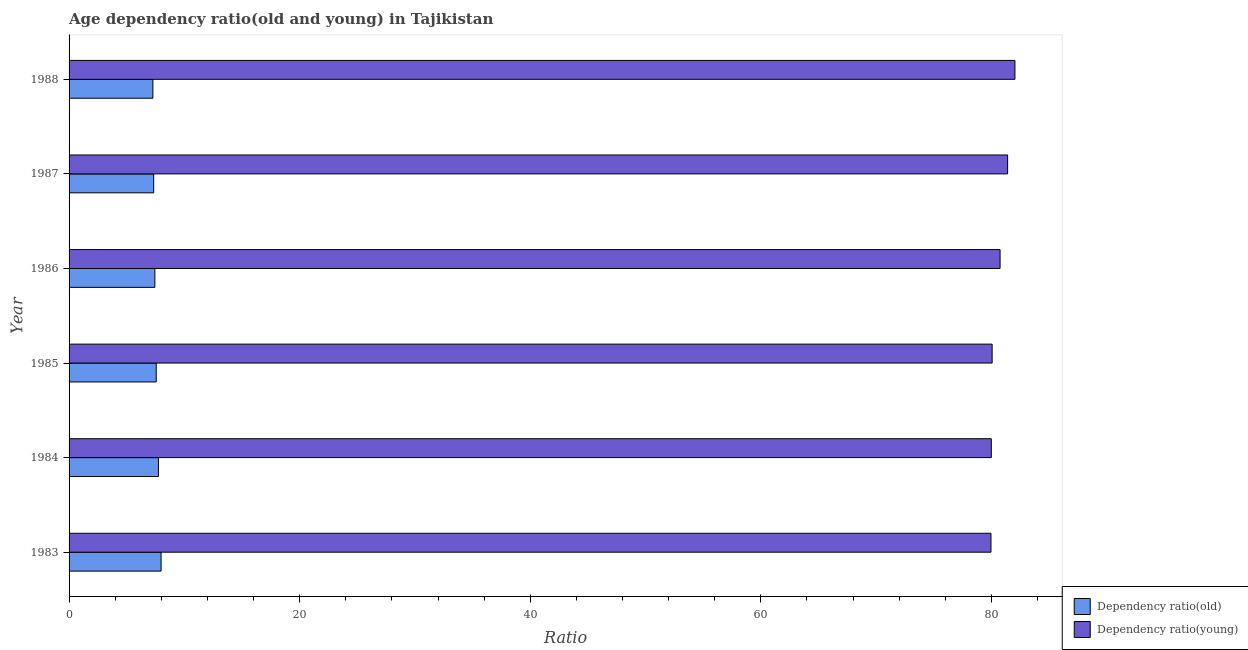How many groups of bars are there?
Keep it short and to the point. 6. What is the label of the 5th group of bars from the top?
Provide a succinct answer. 1984. What is the age dependency ratio(young) in 1988?
Provide a short and direct response. 82.04. Across all years, what is the maximum age dependency ratio(old)?
Your answer should be compact. 7.98. Across all years, what is the minimum age dependency ratio(old)?
Offer a very short reply. 7.27. In which year was the age dependency ratio(old) maximum?
Your answer should be compact. 1983. In which year was the age dependency ratio(young) minimum?
Your answer should be very brief. 1983. What is the total age dependency ratio(young) in the graph?
Your response must be concise. 484.23. What is the difference between the age dependency ratio(young) in 1986 and that in 1987?
Provide a succinct answer. -0.65. What is the difference between the age dependency ratio(old) in 1984 and the age dependency ratio(young) in 1986?
Provide a succinct answer. -73. What is the average age dependency ratio(old) per year?
Your response must be concise. 7.56. In the year 1988, what is the difference between the age dependency ratio(young) and age dependency ratio(old)?
Provide a short and direct response. 74.77. In how many years, is the age dependency ratio(young) greater than 40 ?
Provide a succinct answer. 6. Is the age dependency ratio(old) in 1985 less than that in 1987?
Provide a succinct answer. No. What is the difference between the highest and the second highest age dependency ratio(young)?
Your answer should be very brief. 0.64. What is the difference between the highest and the lowest age dependency ratio(young)?
Offer a very short reply. 2.08. In how many years, is the age dependency ratio(young) greater than the average age dependency ratio(young) taken over all years?
Your answer should be compact. 3. What does the 1st bar from the top in 1983 represents?
Offer a very short reply. Dependency ratio(young). What does the 1st bar from the bottom in 1983 represents?
Offer a very short reply. Dependency ratio(old). How many bars are there?
Give a very brief answer. 12. Are all the bars in the graph horizontal?
Offer a terse response. Yes. What is the difference between two consecutive major ticks on the X-axis?
Ensure brevity in your answer.  20. Are the values on the major ticks of X-axis written in scientific E-notation?
Make the answer very short. No. How many legend labels are there?
Provide a short and direct response. 2. How are the legend labels stacked?
Provide a short and direct response. Vertical. What is the title of the graph?
Make the answer very short. Age dependency ratio(old and young) in Tajikistan. What is the label or title of the X-axis?
Give a very brief answer. Ratio. What is the Ratio in Dependency ratio(old) in 1983?
Provide a succinct answer. 7.98. What is the Ratio of Dependency ratio(young) in 1983?
Give a very brief answer. 79.96. What is the Ratio in Dependency ratio(old) in 1984?
Keep it short and to the point. 7.75. What is the Ratio in Dependency ratio(young) in 1984?
Give a very brief answer. 79.99. What is the Ratio of Dependency ratio(old) in 1985?
Give a very brief answer. 7.56. What is the Ratio in Dependency ratio(young) in 1985?
Your answer should be compact. 80.07. What is the Ratio of Dependency ratio(old) in 1986?
Your answer should be compact. 7.44. What is the Ratio of Dependency ratio(young) in 1986?
Ensure brevity in your answer.  80.75. What is the Ratio of Dependency ratio(old) in 1987?
Offer a terse response. 7.34. What is the Ratio in Dependency ratio(young) in 1987?
Provide a succinct answer. 81.41. What is the Ratio in Dependency ratio(old) in 1988?
Your response must be concise. 7.27. What is the Ratio of Dependency ratio(young) in 1988?
Offer a very short reply. 82.04. Across all years, what is the maximum Ratio in Dependency ratio(old)?
Provide a succinct answer. 7.98. Across all years, what is the maximum Ratio in Dependency ratio(young)?
Ensure brevity in your answer.  82.04. Across all years, what is the minimum Ratio in Dependency ratio(old)?
Your response must be concise. 7.27. Across all years, what is the minimum Ratio in Dependency ratio(young)?
Ensure brevity in your answer.  79.96. What is the total Ratio of Dependency ratio(old) in the graph?
Provide a succinct answer. 45.35. What is the total Ratio of Dependency ratio(young) in the graph?
Offer a very short reply. 484.23. What is the difference between the Ratio in Dependency ratio(old) in 1983 and that in 1984?
Ensure brevity in your answer.  0.23. What is the difference between the Ratio of Dependency ratio(young) in 1983 and that in 1984?
Offer a terse response. -0.03. What is the difference between the Ratio of Dependency ratio(old) in 1983 and that in 1985?
Offer a terse response. 0.42. What is the difference between the Ratio of Dependency ratio(young) in 1983 and that in 1985?
Offer a terse response. -0.1. What is the difference between the Ratio of Dependency ratio(old) in 1983 and that in 1986?
Your response must be concise. 0.54. What is the difference between the Ratio of Dependency ratio(young) in 1983 and that in 1986?
Your answer should be compact. -0.79. What is the difference between the Ratio of Dependency ratio(old) in 1983 and that in 1987?
Keep it short and to the point. 0.64. What is the difference between the Ratio of Dependency ratio(young) in 1983 and that in 1987?
Your answer should be compact. -1.44. What is the difference between the Ratio in Dependency ratio(old) in 1983 and that in 1988?
Offer a very short reply. 0.71. What is the difference between the Ratio in Dependency ratio(young) in 1983 and that in 1988?
Your response must be concise. -2.08. What is the difference between the Ratio in Dependency ratio(old) in 1984 and that in 1985?
Make the answer very short. 0.19. What is the difference between the Ratio in Dependency ratio(young) in 1984 and that in 1985?
Ensure brevity in your answer.  -0.07. What is the difference between the Ratio in Dependency ratio(old) in 1984 and that in 1986?
Give a very brief answer. 0.31. What is the difference between the Ratio in Dependency ratio(young) in 1984 and that in 1986?
Provide a succinct answer. -0.76. What is the difference between the Ratio in Dependency ratio(old) in 1984 and that in 1987?
Ensure brevity in your answer.  0.41. What is the difference between the Ratio in Dependency ratio(young) in 1984 and that in 1987?
Your answer should be very brief. -1.41. What is the difference between the Ratio of Dependency ratio(old) in 1984 and that in 1988?
Your response must be concise. 0.48. What is the difference between the Ratio of Dependency ratio(young) in 1984 and that in 1988?
Your response must be concise. -2.05. What is the difference between the Ratio in Dependency ratio(old) in 1985 and that in 1986?
Offer a very short reply. 0.12. What is the difference between the Ratio of Dependency ratio(young) in 1985 and that in 1986?
Your answer should be compact. -0.69. What is the difference between the Ratio in Dependency ratio(old) in 1985 and that in 1987?
Provide a succinct answer. 0.22. What is the difference between the Ratio in Dependency ratio(young) in 1985 and that in 1987?
Your answer should be very brief. -1.34. What is the difference between the Ratio in Dependency ratio(old) in 1985 and that in 1988?
Provide a short and direct response. 0.29. What is the difference between the Ratio in Dependency ratio(young) in 1985 and that in 1988?
Ensure brevity in your answer.  -1.98. What is the difference between the Ratio of Dependency ratio(old) in 1986 and that in 1987?
Offer a very short reply. 0.1. What is the difference between the Ratio of Dependency ratio(young) in 1986 and that in 1987?
Provide a short and direct response. -0.65. What is the difference between the Ratio in Dependency ratio(old) in 1986 and that in 1988?
Offer a terse response. 0.17. What is the difference between the Ratio in Dependency ratio(young) in 1986 and that in 1988?
Offer a terse response. -1.29. What is the difference between the Ratio of Dependency ratio(old) in 1987 and that in 1988?
Offer a very short reply. 0.07. What is the difference between the Ratio in Dependency ratio(young) in 1987 and that in 1988?
Offer a very short reply. -0.63. What is the difference between the Ratio of Dependency ratio(old) in 1983 and the Ratio of Dependency ratio(young) in 1984?
Provide a short and direct response. -72.01. What is the difference between the Ratio of Dependency ratio(old) in 1983 and the Ratio of Dependency ratio(young) in 1985?
Make the answer very short. -72.08. What is the difference between the Ratio in Dependency ratio(old) in 1983 and the Ratio in Dependency ratio(young) in 1986?
Provide a succinct answer. -72.77. What is the difference between the Ratio of Dependency ratio(old) in 1983 and the Ratio of Dependency ratio(young) in 1987?
Make the answer very short. -73.43. What is the difference between the Ratio of Dependency ratio(old) in 1983 and the Ratio of Dependency ratio(young) in 1988?
Provide a succinct answer. -74.06. What is the difference between the Ratio of Dependency ratio(old) in 1984 and the Ratio of Dependency ratio(young) in 1985?
Your answer should be compact. -72.31. What is the difference between the Ratio in Dependency ratio(old) in 1984 and the Ratio in Dependency ratio(young) in 1986?
Your answer should be very brief. -73. What is the difference between the Ratio in Dependency ratio(old) in 1984 and the Ratio in Dependency ratio(young) in 1987?
Your response must be concise. -73.66. What is the difference between the Ratio of Dependency ratio(old) in 1984 and the Ratio of Dependency ratio(young) in 1988?
Offer a very short reply. -74.29. What is the difference between the Ratio in Dependency ratio(old) in 1985 and the Ratio in Dependency ratio(young) in 1986?
Your answer should be very brief. -73.19. What is the difference between the Ratio in Dependency ratio(old) in 1985 and the Ratio in Dependency ratio(young) in 1987?
Offer a very short reply. -73.85. What is the difference between the Ratio of Dependency ratio(old) in 1985 and the Ratio of Dependency ratio(young) in 1988?
Provide a succinct answer. -74.48. What is the difference between the Ratio of Dependency ratio(old) in 1986 and the Ratio of Dependency ratio(young) in 1987?
Your answer should be very brief. -73.97. What is the difference between the Ratio in Dependency ratio(old) in 1986 and the Ratio in Dependency ratio(young) in 1988?
Your answer should be very brief. -74.6. What is the difference between the Ratio in Dependency ratio(old) in 1987 and the Ratio in Dependency ratio(young) in 1988?
Ensure brevity in your answer.  -74.7. What is the average Ratio in Dependency ratio(old) per year?
Give a very brief answer. 7.56. What is the average Ratio of Dependency ratio(young) per year?
Your response must be concise. 80.71. In the year 1983, what is the difference between the Ratio of Dependency ratio(old) and Ratio of Dependency ratio(young)?
Provide a short and direct response. -71.98. In the year 1984, what is the difference between the Ratio of Dependency ratio(old) and Ratio of Dependency ratio(young)?
Offer a very short reply. -72.24. In the year 1985, what is the difference between the Ratio in Dependency ratio(old) and Ratio in Dependency ratio(young)?
Your answer should be very brief. -72.51. In the year 1986, what is the difference between the Ratio of Dependency ratio(old) and Ratio of Dependency ratio(young)?
Ensure brevity in your answer.  -73.31. In the year 1987, what is the difference between the Ratio in Dependency ratio(old) and Ratio in Dependency ratio(young)?
Your answer should be compact. -74.07. In the year 1988, what is the difference between the Ratio of Dependency ratio(old) and Ratio of Dependency ratio(young)?
Your answer should be very brief. -74.77. What is the ratio of the Ratio in Dependency ratio(old) in 1983 to that in 1984?
Your response must be concise. 1.03. What is the ratio of the Ratio of Dependency ratio(young) in 1983 to that in 1984?
Provide a short and direct response. 1. What is the ratio of the Ratio in Dependency ratio(old) in 1983 to that in 1985?
Offer a terse response. 1.06. What is the ratio of the Ratio of Dependency ratio(young) in 1983 to that in 1985?
Offer a very short reply. 1. What is the ratio of the Ratio of Dependency ratio(old) in 1983 to that in 1986?
Give a very brief answer. 1.07. What is the ratio of the Ratio of Dependency ratio(young) in 1983 to that in 1986?
Your answer should be compact. 0.99. What is the ratio of the Ratio of Dependency ratio(old) in 1983 to that in 1987?
Keep it short and to the point. 1.09. What is the ratio of the Ratio of Dependency ratio(young) in 1983 to that in 1987?
Provide a short and direct response. 0.98. What is the ratio of the Ratio in Dependency ratio(old) in 1983 to that in 1988?
Keep it short and to the point. 1.1. What is the ratio of the Ratio of Dependency ratio(young) in 1983 to that in 1988?
Offer a terse response. 0.97. What is the ratio of the Ratio of Dependency ratio(old) in 1984 to that in 1985?
Provide a short and direct response. 1.03. What is the ratio of the Ratio in Dependency ratio(young) in 1984 to that in 1985?
Offer a terse response. 1. What is the ratio of the Ratio of Dependency ratio(old) in 1984 to that in 1986?
Give a very brief answer. 1.04. What is the ratio of the Ratio of Dependency ratio(young) in 1984 to that in 1986?
Provide a short and direct response. 0.99. What is the ratio of the Ratio of Dependency ratio(old) in 1984 to that in 1987?
Your answer should be compact. 1.06. What is the ratio of the Ratio in Dependency ratio(young) in 1984 to that in 1987?
Your answer should be very brief. 0.98. What is the ratio of the Ratio in Dependency ratio(old) in 1984 to that in 1988?
Provide a short and direct response. 1.07. What is the ratio of the Ratio of Dependency ratio(young) in 1984 to that in 1988?
Provide a succinct answer. 0.97. What is the ratio of the Ratio in Dependency ratio(old) in 1985 to that in 1986?
Provide a short and direct response. 1.02. What is the ratio of the Ratio in Dependency ratio(old) in 1985 to that in 1987?
Provide a short and direct response. 1.03. What is the ratio of the Ratio of Dependency ratio(young) in 1985 to that in 1987?
Your response must be concise. 0.98. What is the ratio of the Ratio of Dependency ratio(old) in 1985 to that in 1988?
Offer a very short reply. 1.04. What is the ratio of the Ratio in Dependency ratio(young) in 1985 to that in 1988?
Your answer should be very brief. 0.98. What is the ratio of the Ratio of Dependency ratio(old) in 1986 to that in 1987?
Offer a very short reply. 1.01. What is the ratio of the Ratio in Dependency ratio(old) in 1986 to that in 1988?
Keep it short and to the point. 1.02. What is the ratio of the Ratio of Dependency ratio(young) in 1986 to that in 1988?
Your answer should be compact. 0.98. What is the ratio of the Ratio of Dependency ratio(old) in 1987 to that in 1988?
Your response must be concise. 1.01. What is the difference between the highest and the second highest Ratio of Dependency ratio(old)?
Your answer should be very brief. 0.23. What is the difference between the highest and the second highest Ratio of Dependency ratio(young)?
Keep it short and to the point. 0.63. What is the difference between the highest and the lowest Ratio of Dependency ratio(old)?
Your answer should be compact. 0.71. What is the difference between the highest and the lowest Ratio of Dependency ratio(young)?
Ensure brevity in your answer.  2.08. 